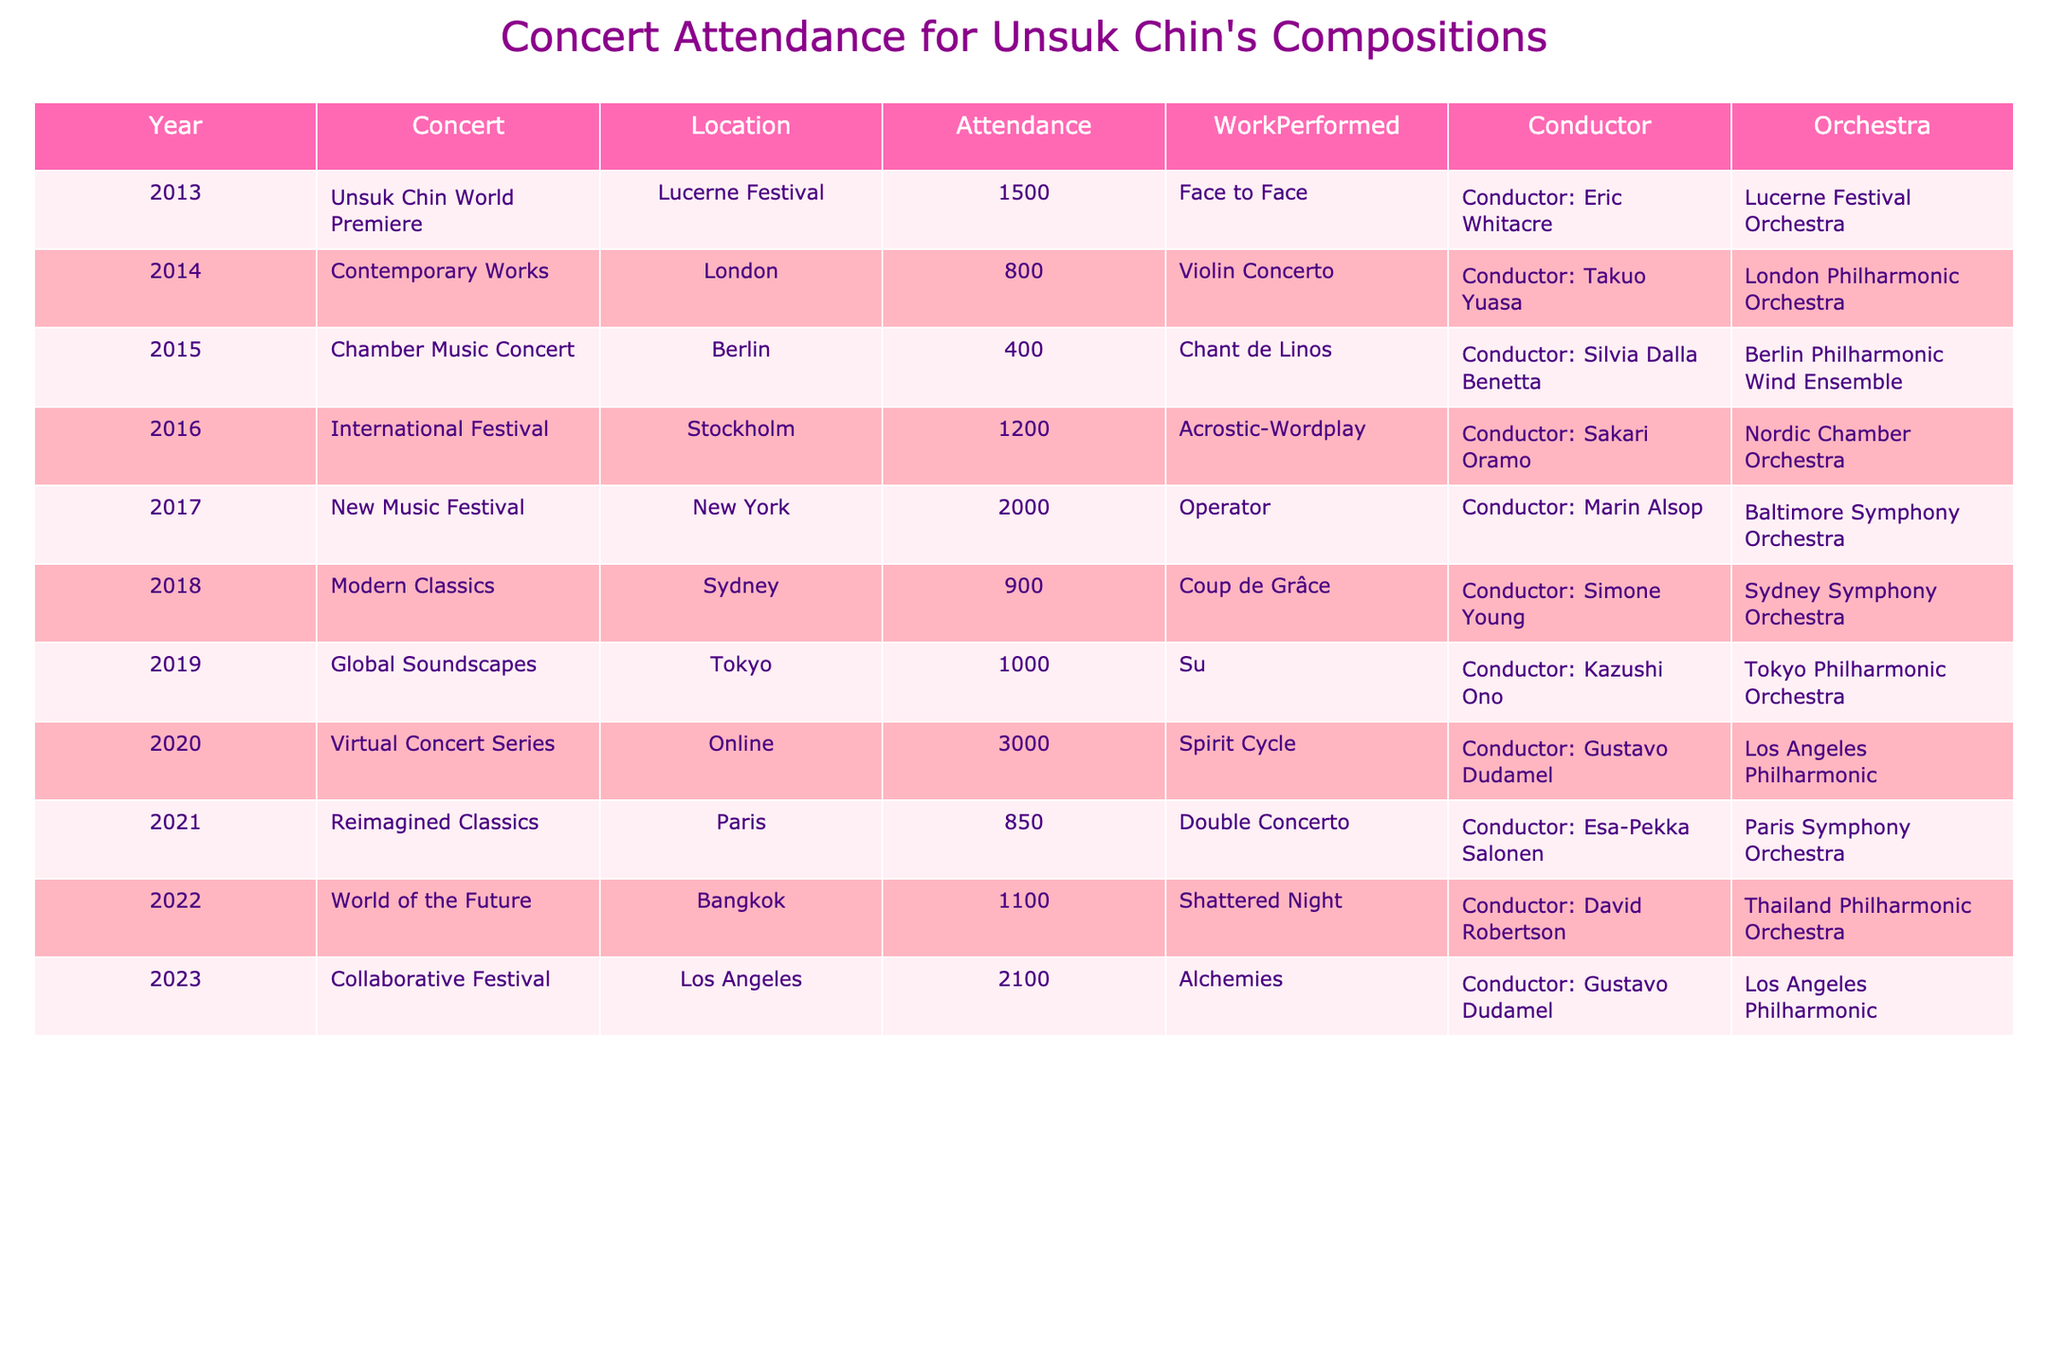What was the highest concert attendance for Unsuk Chin's compositions? The table shows attendance figures for each concert. From the data, the highest attendance is in 2020 with 3000 attendees for the Virtual Concert Series.
Answer: 3000 In which year was the Violin Concerto performed and what was the attendance? The table lists that the Violin Concerto was performed in 2014, with an attendance of 800.
Answer: 2014, 800 What is the average attendance for concerts conducted by Gustavo Dudamel? There are two concerts conducted by Gustavo Dudamel: the Virtual Concert Series in 2020 with 3000 attendees and the Collaborative Festival in 2023 with 2100 attendees. Summing these gives 3000 + 2100 = 5100. Dividing by 2 yields an average of 5100 / 2 = 2550.
Answer: 2550 Did the attendance for concerts in 2019 exceed 1500? Checking the table, the attendance figure for 2019 is 1000, which does not exceed 1500.
Answer: No Which orchestra had the highest attendance concert and what was that concert? The highest attendance concert is the Virtual Concert Series conducted by Gustavo Dudamel with 3000 attendees. The corresponding orchestra is the Los Angeles Philharmonic.
Answer: Virtual Concert Series, Los Angeles Philharmonic What is the total attendance across all concerts in 2013, 2014, and 2015? The attendances for these years are 1500 (2013), 800 (2014), and 400 (2015). Summing these figures gives 1500 + 800 + 400 = 2700.
Answer: 2700 How many concerts had an attendance of over 1000? Examining the table, the concerts with attendance over 1000 are the Virtual Concert Series (3000), New Music Festival (2000), Collaborative Festival (2100), and World of the Future (1100), totaling 4 concerts.
Answer: 4 What work was performed in 2016 and was the attendance higher or lower than the 2017 concert? In 2016, the work performed was Acrostic-Wordplay with an attendance of 1200. The 2017 New Music Festival had an attendance of 2000. Since 1200 is lower than 2000, the answer is lower.
Answer: Lower Which location had the lowest concert attendance and what was the attendance? From the table, the Chamber Music Concert in Berlin had the lowest attendance with 400.
Answer: Berlin, 400 